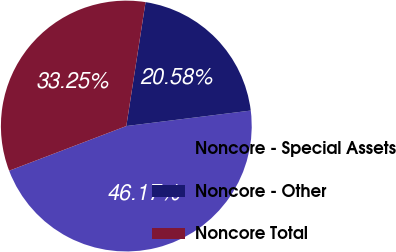Convert chart. <chart><loc_0><loc_0><loc_500><loc_500><pie_chart><fcel>Noncore - Special Assets<fcel>Noncore - Other<fcel>Noncore Total<nl><fcel>46.17%<fcel>20.58%<fcel>33.25%<nl></chart> 